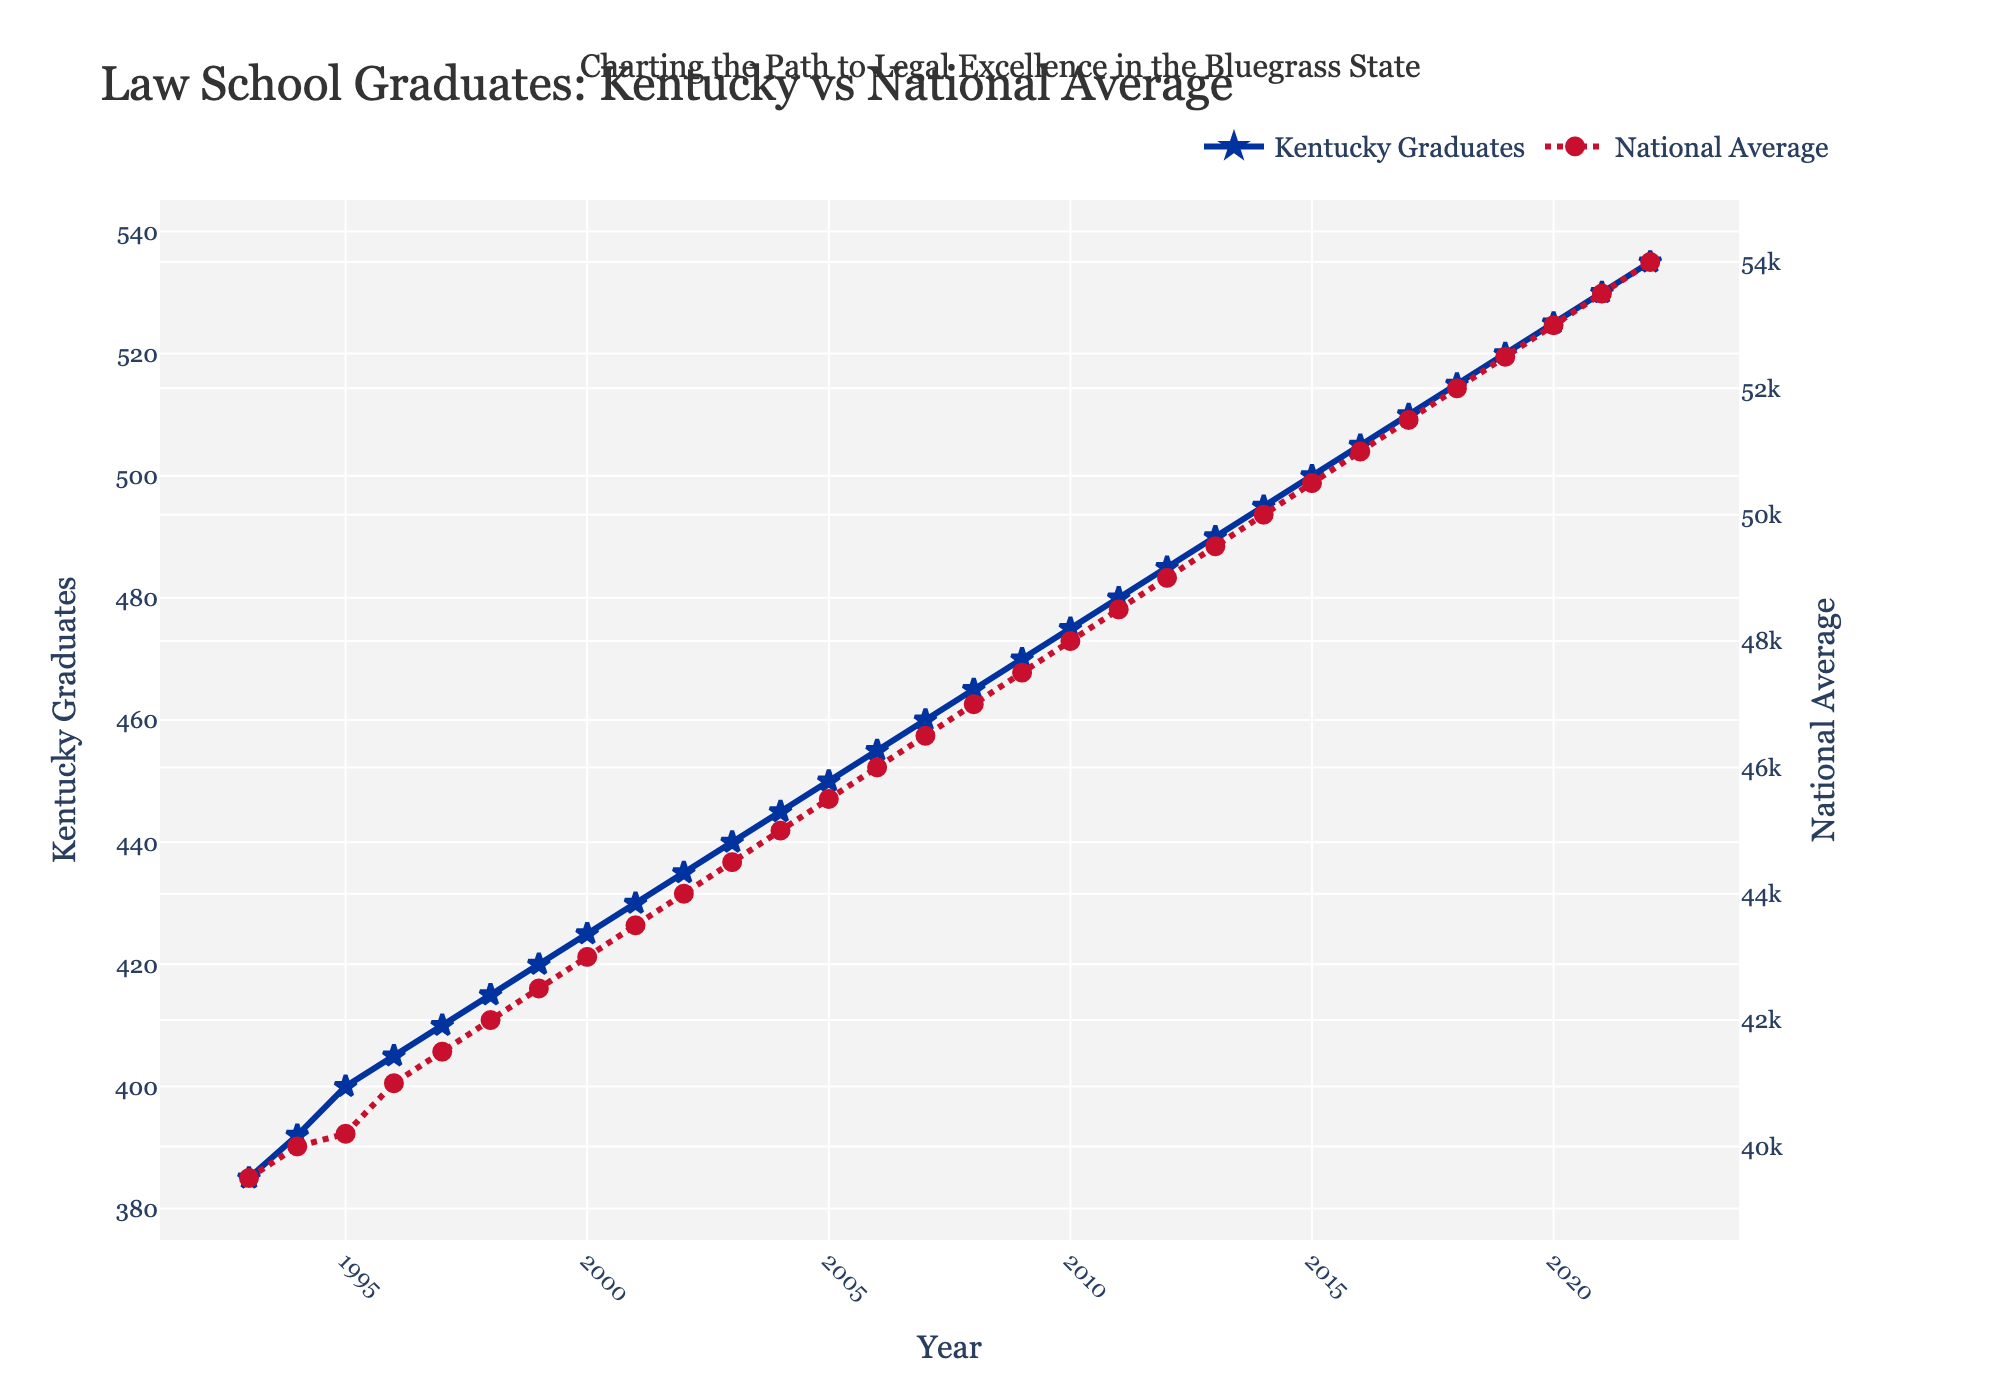What's the overall trend for Kentucky graduates over the 30-year period? By observing the line for Kentucky graduates, we can see it shows a general upward trend from 1993 to 2022, starting at 385 and ending at 535.
Answer: Upward trend Which year had the lowest number of Kentucky law school graduates? The line for Kentucky graduates starts at its lowest point in 1993, with 385 graduates.
Answer: 1993 How does the growth rate of law school graduates in Kentucky compare to the national average? Both Kentucky and the national average show a similar steady growth. However, the national average starts at 39,500 and ends at 54,000, while Kentucky starts at 385 and ends at 535. This indicates that both experienced growth but on different scales.
Answer: Similar steady growth What's the approximate difference in the number of graduates between Kentucky and the national average in 2022? The number of graduates in Kentucky in 2022 is 535, and the national average is 54,000. The difference is 54,000 - 535 = 53,465.
Answer: 53,465 In which year was the gap between Kentucky graduates and the national average the smallest? To find the year with the smallest gap, compare the differences each year. The smallest difference appears in 1993 with 39,500 (national) - 385 (Kentucky) = 39,115.
Answer: 1993 What visual feature distinguishes the Kentucky graduate line from the national average line? The Kentucky graduate line is solid blue with star markers, while the national average line is red with a dashed pattern and circle markers.
Answer: Blue line with stars vs. red dashed line with circles Between which years did Kentucky experience the most significant increase in law school graduates? By examining the graph, the steepest increase seems to happen gradually over time, but notable jumps can be seen around the mid-2000s and early 2020s.
Answer: Mid-2000s and early 2020s What is the shape of the markers used for Kentucky graduates on the plot? The Kentucky graduates' line uses star-shaped markers.
Answer: Star-shaped markers What year had exactly 500 Kentucky graduates, and what was the national average that year? Referring to the Kentucky line, in 2015, there were 500 graduates. The national average that same year shows 50,500 graduates.
Answer: 2015, 50,500 How does the number of Kentucky law school graduates in 2010 compare to 2020? In 2010, Kentucky had 475 graduates, while in 2020, it had 525. This indicates an increase of 50 graduates over the decade.
Answer: 50 more graduates in 2020 